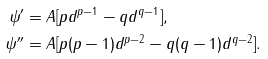<formula> <loc_0><loc_0><loc_500><loc_500>\psi ^ { \prime } & = A [ p d ^ { p - 1 } - q d ^ { q - 1 } ] , \\ \psi ^ { \prime \prime } & = A [ p ( p - 1 ) d ^ { p - 2 } - q ( q - 1 ) d ^ { q - 2 } ] .</formula> 